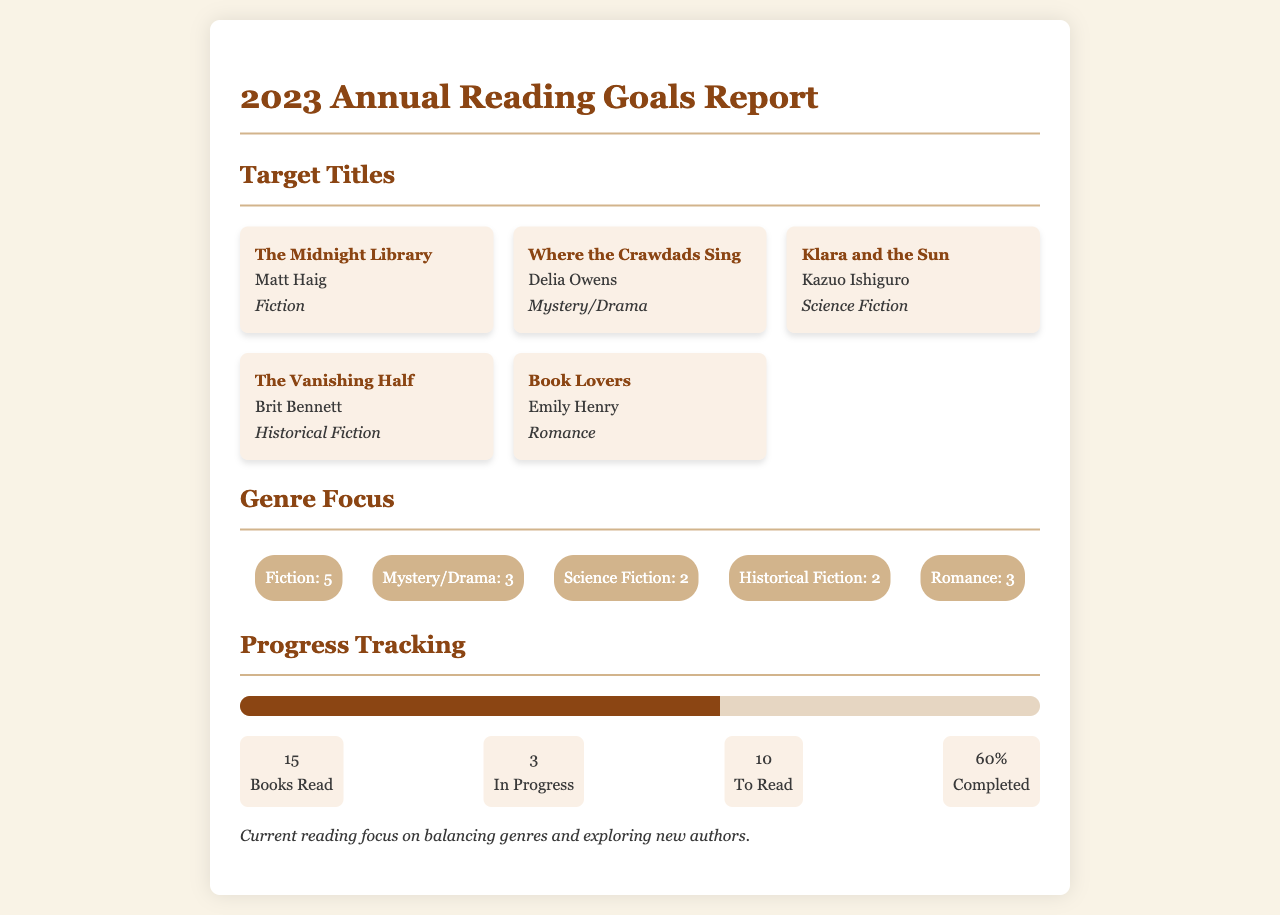What is the title of the first book listed? The title of the first book is in the "Target Titles" section, which is "The Midnight Library."
Answer: The Midnight Library Who is the author of "Where the Crawdads Sing"? "Where the Crawdads Sing" is in the "Target Titles" section, authored by Delia Owens.
Answer: Delia Owens How many genres are listed in the genre focus section? The "Genre Focus" section shows a total of five different genres listed.
Answer: 5 What percentage of books read is completed? The "Progress Tracking" section states that 60% of the books read are completed.
Answer: 60% How many books are currently in progress? According to the "Progress Tracking" section, there are 3 books in progress.
Answer: 3 Which genre has the highest count? "Fiction" has the highest count among the genres listed in the "Genre Focus" section with a total of 5.
Answer: Fiction What is the total number of books read? The total number of books read is found in the "Progress Tracking" section, which states 15.
Answer: 15 Which book belongs to the Romance genre? In the "Target Titles" section, the book "Book Lovers" is associated with the Romance genre.
Answer: Book Lovers How many books are tagged as Science Fiction? The "Genre Focus" section indicates that there are 2 books categorized as Science Fiction.
Answer: 2 